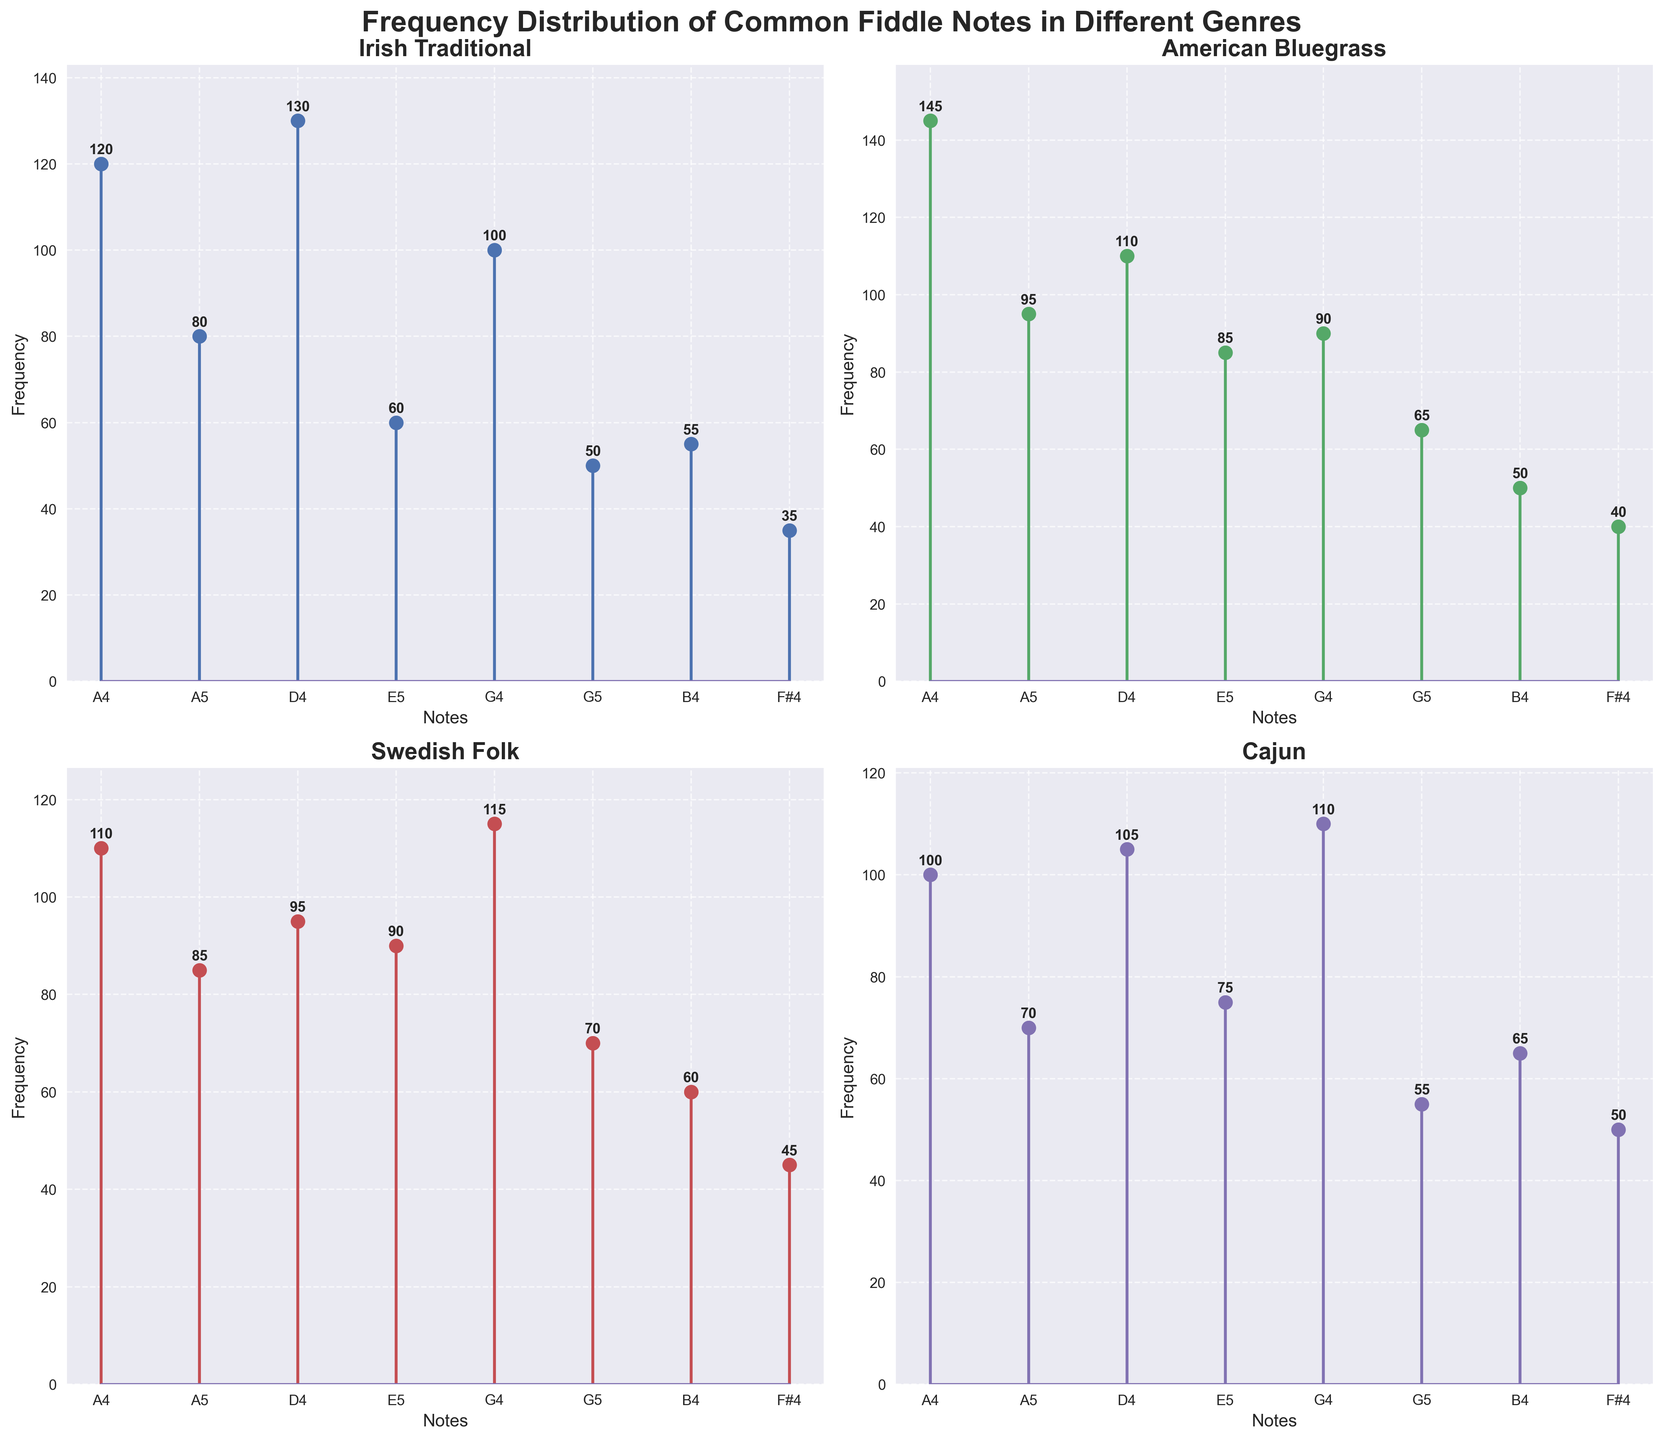What's the title of the figure? The title is typically displayed at the top of the figure. In this case, it's clearly shown as "Frequency Distribution of Common Fiddle Notes in Different Genres".
Answer: Frequency Distribution of Common Fiddle Notes in Different Genres Which genre shows the highest frequency for the note A4? By examining all subplots, we focus on the note A4 across genres. The Irish Traditional plot shows a frequency of 120, American Bluegrass shows 145, Swedish Folk shows 110, and Cajun shows 100. The highest value is 145 in the American Bluegrass plot.
Answer: American Bluegrass How many data points are shown on each subplot? Each subplot represents the same set of notes. By counting the markers, we see that there are 8 notes presented in each subplot.
Answer: 8 What is the total frequency of D4 across all genres? Identify the frequency of D4 in each subplot: Irish Traditional (130), American Bluegrass (110), Swedish Folk (95), and Cajun (105). Summing these values: 130 + 110 + 95 + 105 = 440.
Answer: 440 Which note has the lowest frequency in Swedish Folk? By inspecting the Swedish Folk subplot, the note F#4 has the lowest frequency, which is 45.
Answer: F#4 Which genre has the most balanced distribution of frequencies? The balance can be evaluated by visual consistency in the heights of the stems. The Cajun subplot shows more consistency in the frequencies across different notes, without large spikes or dips.
Answer: Cajun What is the difference between the highest and lowest frequencies for the note E5 in Irish Traditional and Cajun genres? Irish Traditional for E5 is 60, Cajun for E5 is 75. The difference: 75 - 60 = 15.
Answer: 15 What is the average frequency of the note G4 in all genres? Frequencies for G4: Irish Traditional (100), American Bluegrass (90), Swedish Folk (115), and Cajun (110). Summing these values: 100 + 90 + 115 + 110 = 415. Dividing by the number of genres (4): 415 / 4 = 103.75.
Answer: 103.75 Which note appears with the least frequency in Irish Traditional music? By looking at the Irish Traditional subplot, the note F#4 appears the least with a frequency of 35.
Answer: F#4 